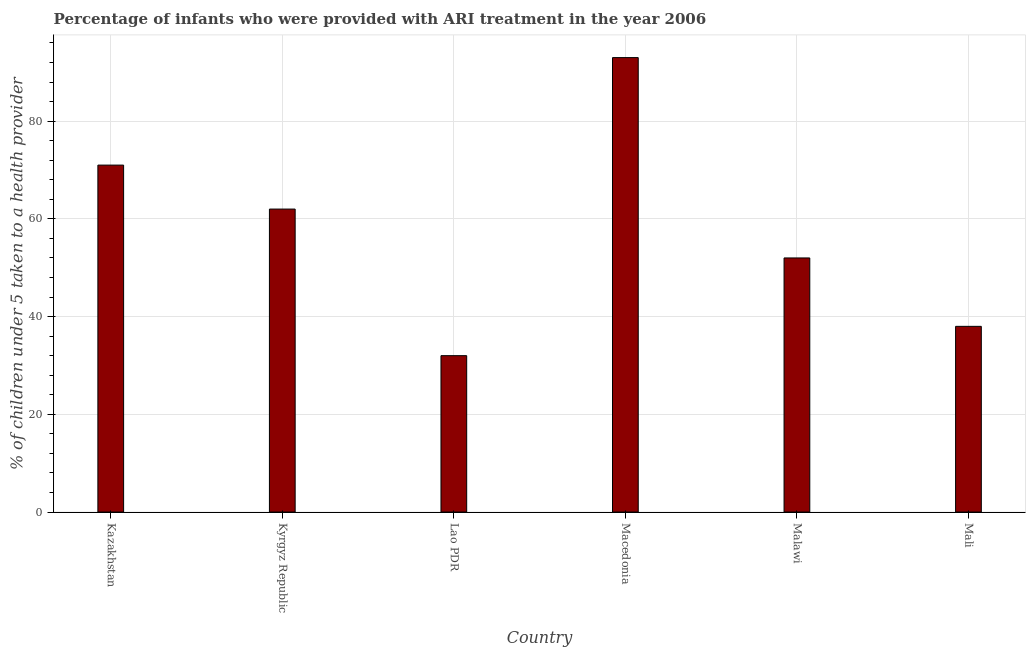Does the graph contain any zero values?
Ensure brevity in your answer.  No. Does the graph contain grids?
Your answer should be very brief. Yes. What is the title of the graph?
Give a very brief answer. Percentage of infants who were provided with ARI treatment in the year 2006. What is the label or title of the Y-axis?
Offer a terse response. % of children under 5 taken to a health provider. What is the percentage of children who were provided with ari treatment in Macedonia?
Provide a succinct answer. 93. Across all countries, what is the maximum percentage of children who were provided with ari treatment?
Give a very brief answer. 93. In which country was the percentage of children who were provided with ari treatment maximum?
Offer a very short reply. Macedonia. In which country was the percentage of children who were provided with ari treatment minimum?
Make the answer very short. Lao PDR. What is the sum of the percentage of children who were provided with ari treatment?
Offer a very short reply. 348. In how many countries, is the percentage of children who were provided with ari treatment greater than 68 %?
Provide a short and direct response. 2. What is the ratio of the percentage of children who were provided with ari treatment in Lao PDR to that in Mali?
Offer a very short reply. 0.84. Is the percentage of children who were provided with ari treatment in Kyrgyz Republic less than that in Macedonia?
Provide a short and direct response. Yes. Is the difference between the percentage of children who were provided with ari treatment in Kyrgyz Republic and Malawi greater than the difference between any two countries?
Your response must be concise. No. What is the difference between the highest and the second highest percentage of children who were provided with ari treatment?
Ensure brevity in your answer.  22. Is the sum of the percentage of children who were provided with ari treatment in Kazakhstan and Mali greater than the maximum percentage of children who were provided with ari treatment across all countries?
Your answer should be compact. Yes. In how many countries, is the percentage of children who were provided with ari treatment greater than the average percentage of children who were provided with ari treatment taken over all countries?
Your answer should be compact. 3. How many bars are there?
Your answer should be compact. 6. Are all the bars in the graph horizontal?
Offer a very short reply. No. How many countries are there in the graph?
Offer a very short reply. 6. Are the values on the major ticks of Y-axis written in scientific E-notation?
Give a very brief answer. No. What is the % of children under 5 taken to a health provider of Kazakhstan?
Provide a succinct answer. 71. What is the % of children under 5 taken to a health provider in Kyrgyz Republic?
Provide a short and direct response. 62. What is the % of children under 5 taken to a health provider of Macedonia?
Offer a very short reply. 93. What is the % of children under 5 taken to a health provider in Mali?
Make the answer very short. 38. What is the difference between the % of children under 5 taken to a health provider in Kazakhstan and Macedonia?
Your answer should be very brief. -22. What is the difference between the % of children under 5 taken to a health provider in Kazakhstan and Malawi?
Your answer should be very brief. 19. What is the difference between the % of children under 5 taken to a health provider in Kyrgyz Republic and Lao PDR?
Give a very brief answer. 30. What is the difference between the % of children under 5 taken to a health provider in Kyrgyz Republic and Macedonia?
Make the answer very short. -31. What is the difference between the % of children under 5 taken to a health provider in Lao PDR and Macedonia?
Offer a very short reply. -61. What is the difference between the % of children under 5 taken to a health provider in Macedonia and Mali?
Ensure brevity in your answer.  55. What is the ratio of the % of children under 5 taken to a health provider in Kazakhstan to that in Kyrgyz Republic?
Keep it short and to the point. 1.15. What is the ratio of the % of children under 5 taken to a health provider in Kazakhstan to that in Lao PDR?
Keep it short and to the point. 2.22. What is the ratio of the % of children under 5 taken to a health provider in Kazakhstan to that in Macedonia?
Your answer should be very brief. 0.76. What is the ratio of the % of children under 5 taken to a health provider in Kazakhstan to that in Malawi?
Your answer should be compact. 1.36. What is the ratio of the % of children under 5 taken to a health provider in Kazakhstan to that in Mali?
Your answer should be compact. 1.87. What is the ratio of the % of children under 5 taken to a health provider in Kyrgyz Republic to that in Lao PDR?
Ensure brevity in your answer.  1.94. What is the ratio of the % of children under 5 taken to a health provider in Kyrgyz Republic to that in Macedonia?
Make the answer very short. 0.67. What is the ratio of the % of children under 5 taken to a health provider in Kyrgyz Republic to that in Malawi?
Offer a terse response. 1.19. What is the ratio of the % of children under 5 taken to a health provider in Kyrgyz Republic to that in Mali?
Ensure brevity in your answer.  1.63. What is the ratio of the % of children under 5 taken to a health provider in Lao PDR to that in Macedonia?
Your response must be concise. 0.34. What is the ratio of the % of children under 5 taken to a health provider in Lao PDR to that in Malawi?
Keep it short and to the point. 0.61. What is the ratio of the % of children under 5 taken to a health provider in Lao PDR to that in Mali?
Your answer should be compact. 0.84. What is the ratio of the % of children under 5 taken to a health provider in Macedonia to that in Malawi?
Your answer should be compact. 1.79. What is the ratio of the % of children under 5 taken to a health provider in Macedonia to that in Mali?
Your answer should be very brief. 2.45. What is the ratio of the % of children under 5 taken to a health provider in Malawi to that in Mali?
Provide a succinct answer. 1.37. 